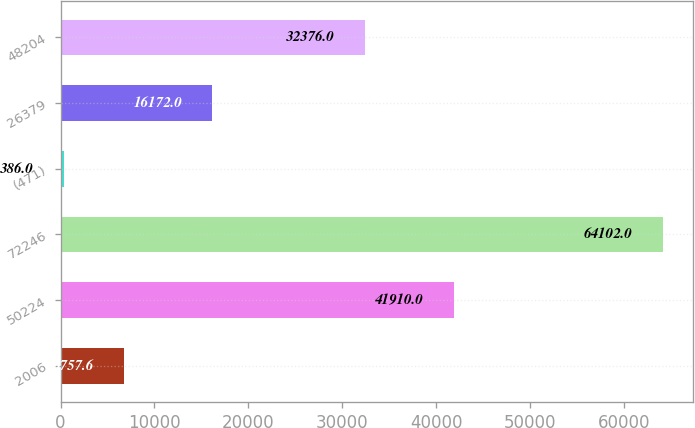Convert chart to OTSL. <chart><loc_0><loc_0><loc_500><loc_500><bar_chart><fcel>2006<fcel>50224<fcel>72246<fcel>(471)<fcel>26379<fcel>48204<nl><fcel>6757.6<fcel>41910<fcel>64102<fcel>386<fcel>16172<fcel>32376<nl></chart> 